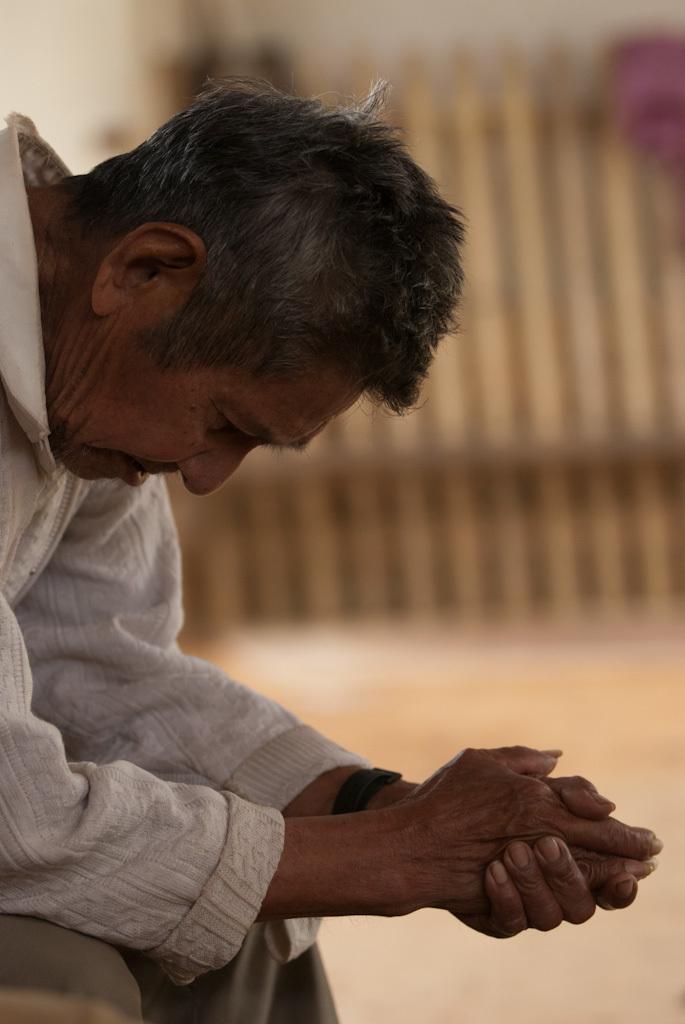In one or two sentences, can you explain what this image depicts? In this image we can see a person. A person is wearing a wrist watch. 